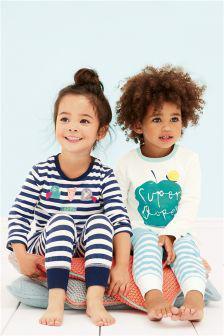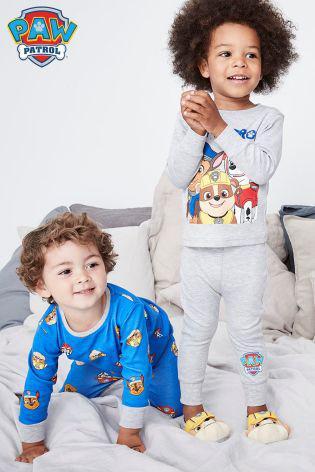The first image is the image on the left, the second image is the image on the right. Given the left and right images, does the statement "An image shows a child modeling a striped top and bottom." hold true? Answer yes or no. Yes. The first image is the image on the left, the second image is the image on the right. For the images shown, is this caption "A boy and girl in the image on the left are sitting down." true? Answer yes or no. No. 